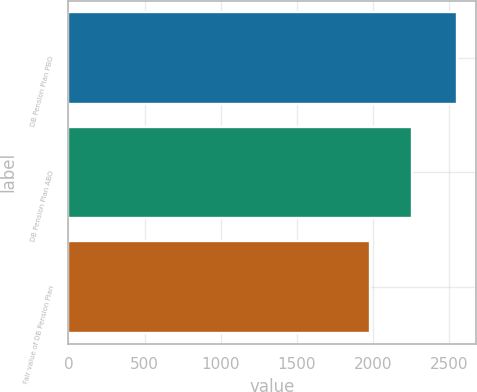Convert chart to OTSL. <chart><loc_0><loc_0><loc_500><loc_500><bar_chart><fcel>DB Pension Plan PBO<fcel>DB Pension Plan ABO<fcel>Fair value of DB Pension Plan<nl><fcel>2547<fcel>2257<fcel>1979<nl></chart> 